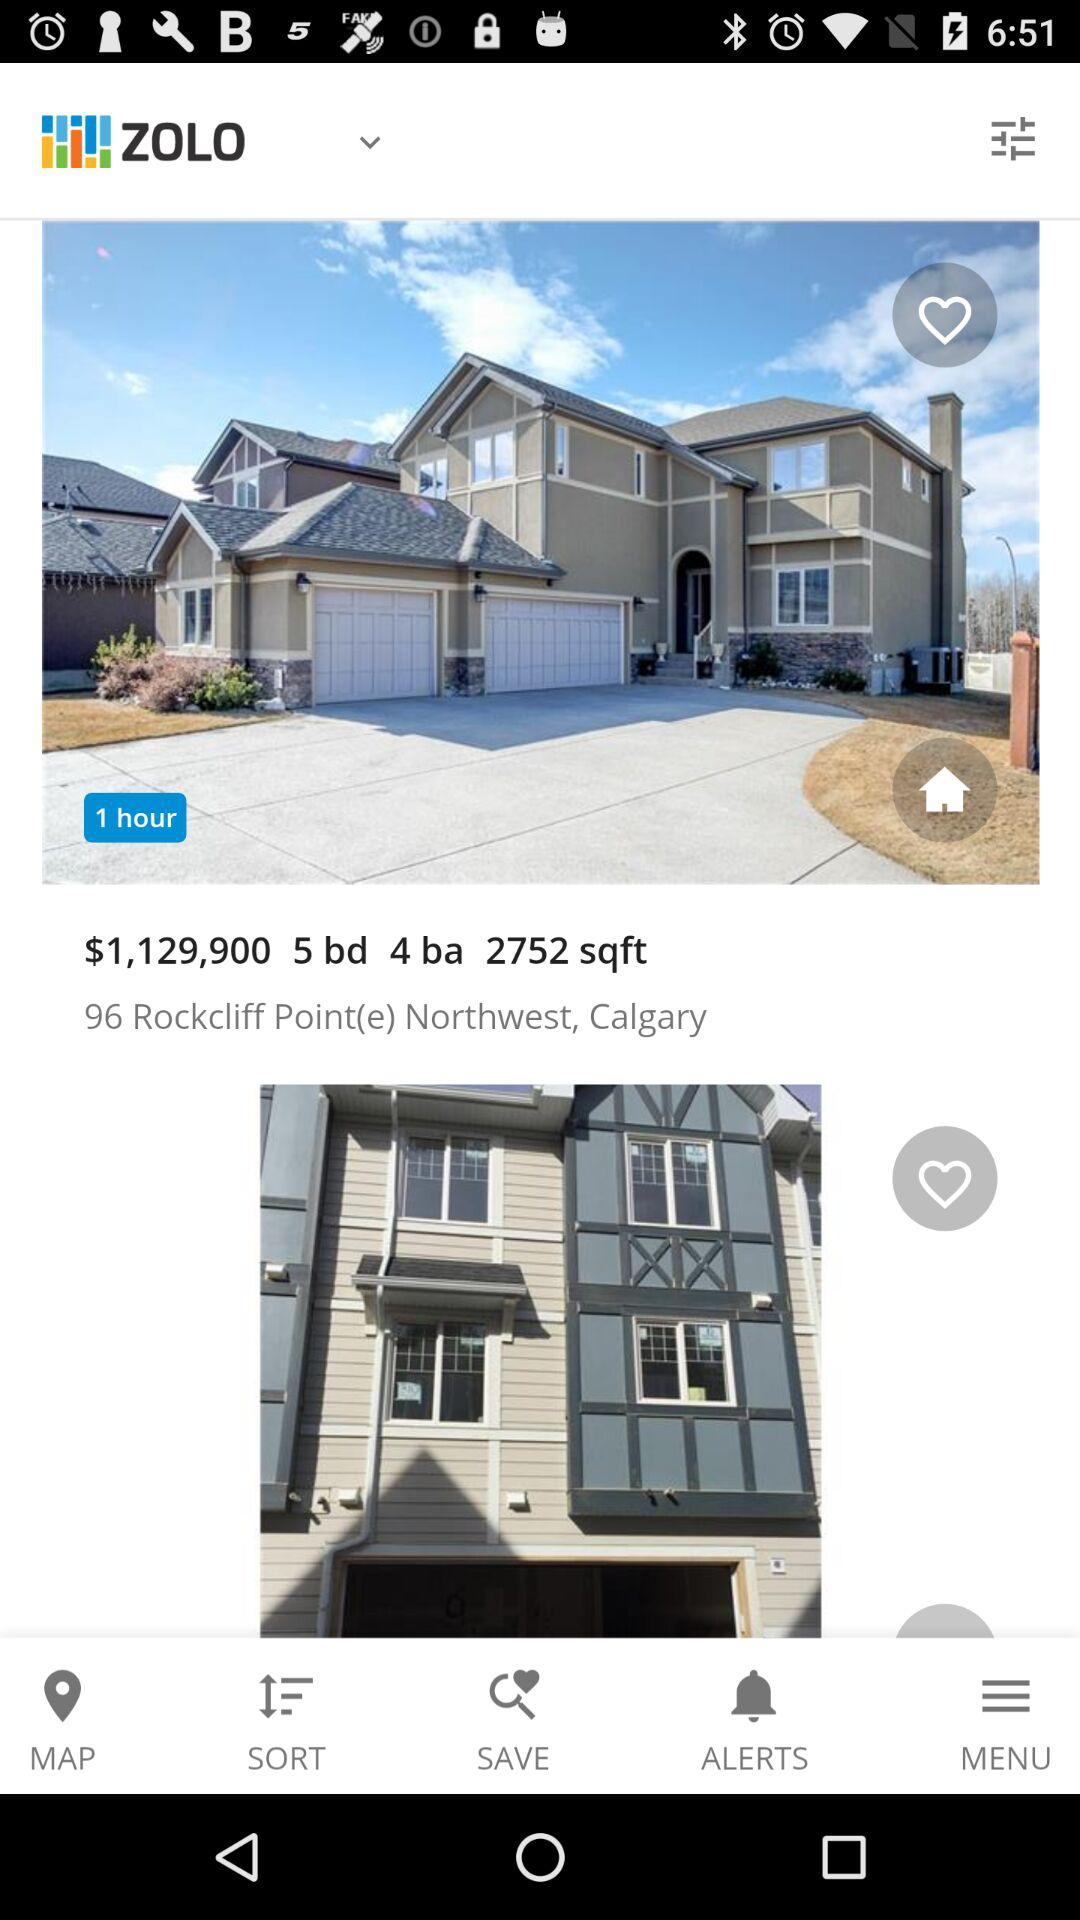What is the given address? The given address is 196 Rockcliff Point(e) Northwest, Calgary. 